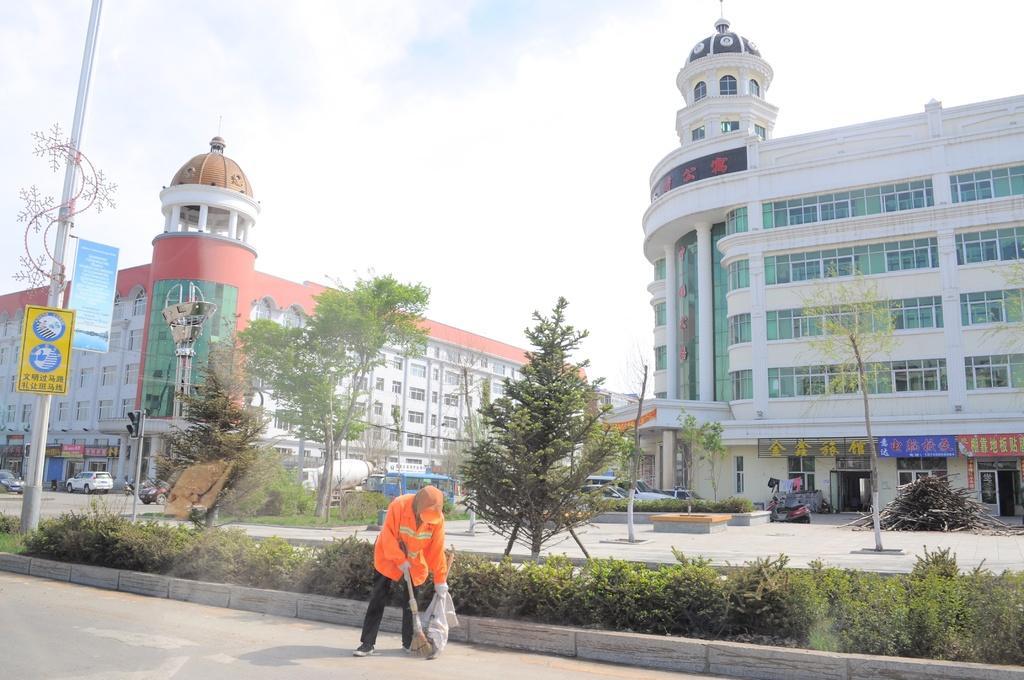Could you give a brief overview of what you see in this image? At the bottom of the image on the road there is a person sweeping. Behind him there are small plants. And also there is a pole with sign board. Behind them there are trees and vehicles on the ground. In the background there are buildings with walls, windows, glasses, posters and roofs. At the top of the image there is sky. 